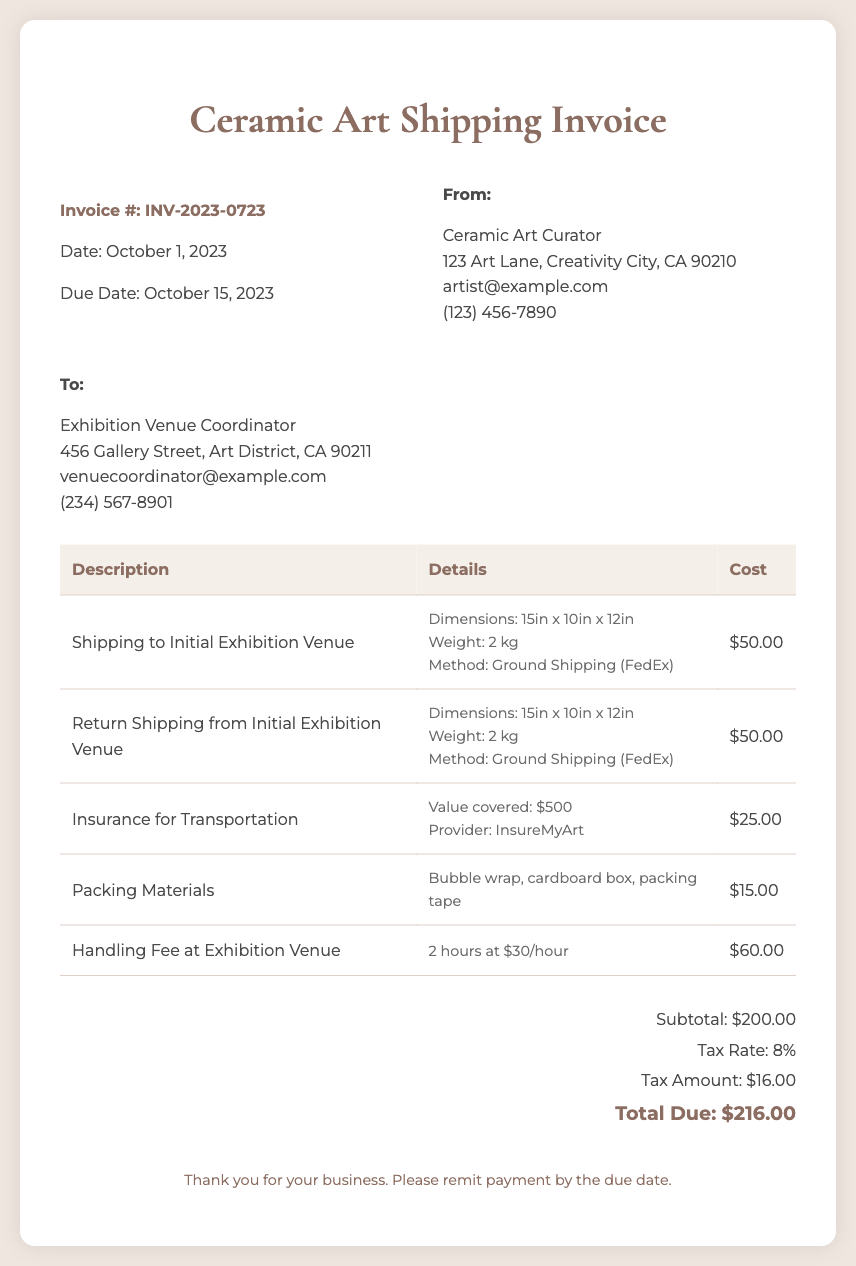What is the invoice number? The invoice number is listed prominently at the top of the document as Invoice #: INV-2023-0723.
Answer: INV-2023-0723 What is the total due amount? The total due amount is calculated at the bottom of the invoice and is stated as Total Due: $216.00.
Answer: $216.00 How much is the handling fee? The handling fee at the exhibition venue is detailed in the invoice, showing it as $60.00.
Answer: $60.00 What is the tax rate applied? The tax rate is indicated in the summary section of the invoice as 8%.
Answer: 8% What is the cost for insurance for transportation? The insurance cost is specified in the document, listed as $25.00.
Answer: $25.00 How many hours are billed for handling at the exhibition venue? The handling fee specifies 2 hours at a rate of $30/hour, indicating the total hours billed.
Answer: 2 hours What method was used for shipping? The method used for shipping to the initial exhibition venue is stated as Ground Shipping (FedEx).
Answer: Ground Shipping (FedEx) What is the subtotal before tax? The subtotal of the invoice is listed just above the tax amount as $200.00.
Answer: $200.00 What date is the invoice due? The due date for the invoice is clearly mentioned as October 15, 2023.
Answer: October 15, 2023 